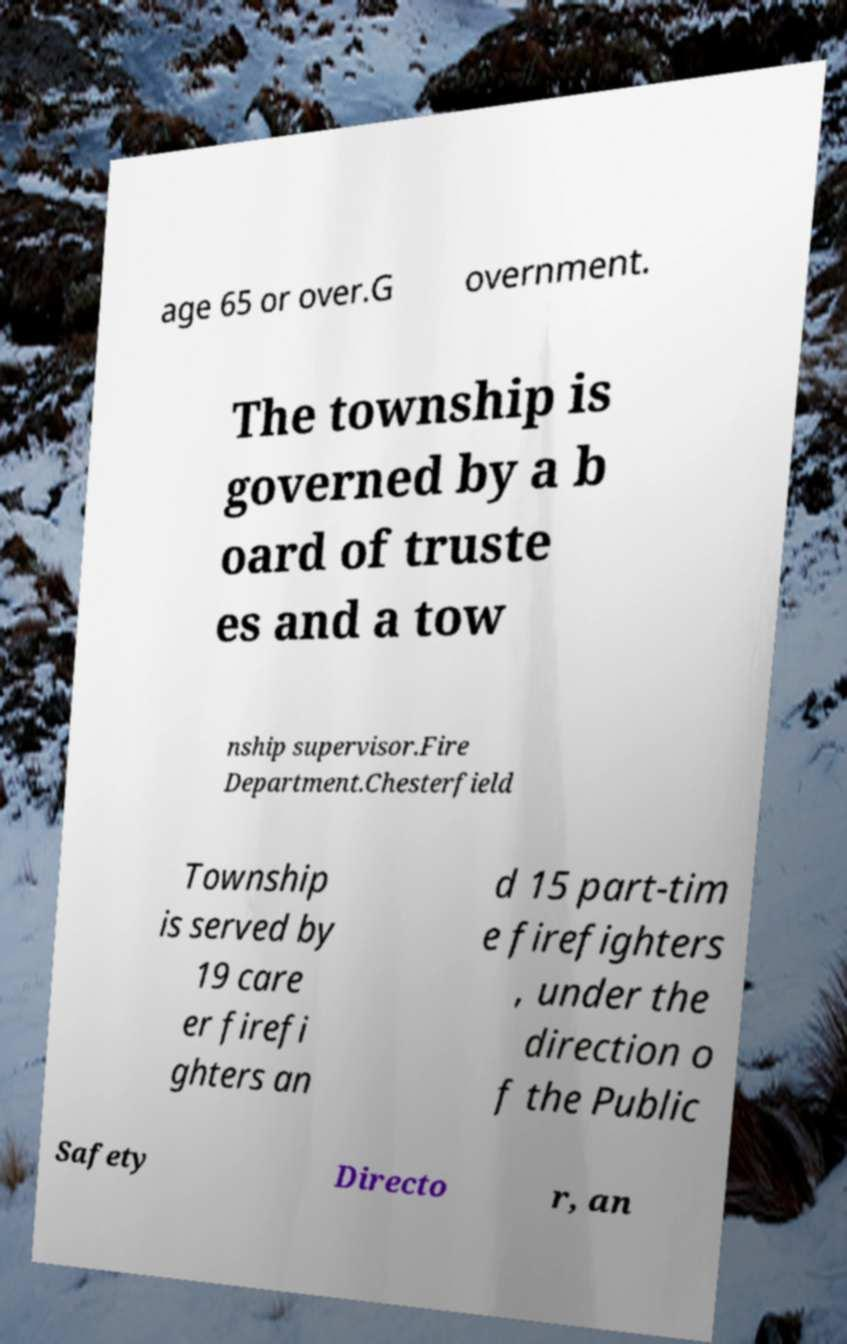Could you extract and type out the text from this image? age 65 or over.G overnment. The township is governed by a b oard of truste es and a tow nship supervisor.Fire Department.Chesterfield Township is served by 19 care er firefi ghters an d 15 part-tim e firefighters , under the direction o f the Public Safety Directo r, an 